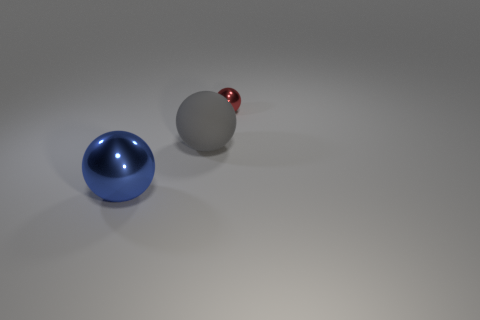Add 2 large objects. How many objects exist? 5 Add 2 large purple things. How many large purple things exist? 2 Subtract 0 gray cylinders. How many objects are left? 3 Subtract all metal things. Subtract all big gray rubber things. How many objects are left? 0 Add 2 large gray objects. How many large gray objects are left? 3 